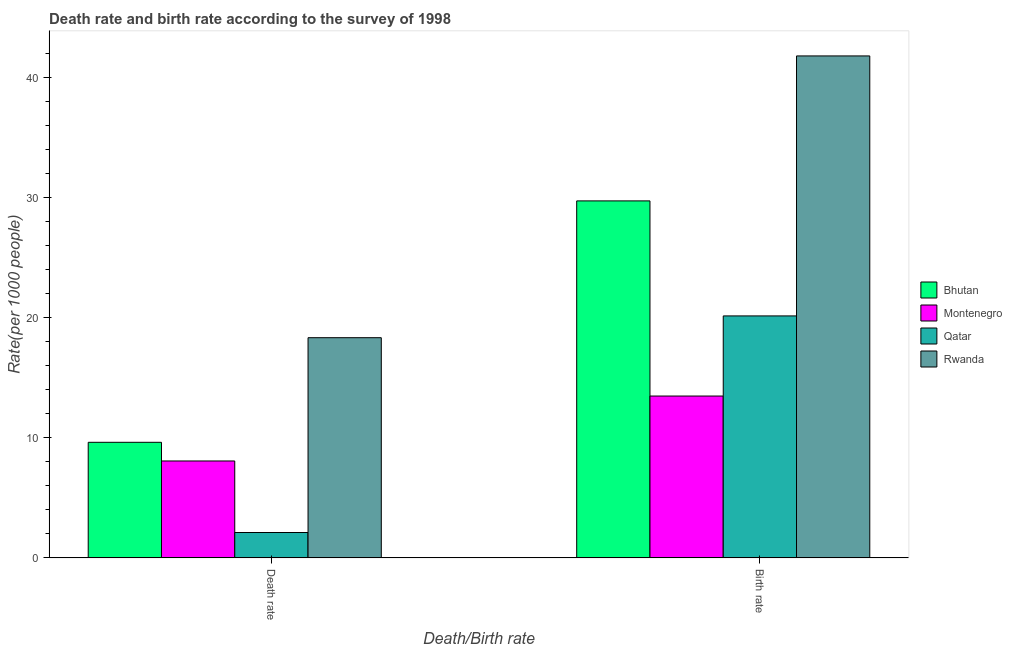How many different coloured bars are there?
Provide a succinct answer. 4. How many bars are there on the 1st tick from the left?
Give a very brief answer. 4. How many bars are there on the 2nd tick from the right?
Your response must be concise. 4. What is the label of the 2nd group of bars from the left?
Your response must be concise. Birth rate. What is the death rate in Montenegro?
Keep it short and to the point. 8.07. Across all countries, what is the maximum death rate?
Give a very brief answer. 18.32. Across all countries, what is the minimum death rate?
Ensure brevity in your answer.  2.11. In which country was the death rate maximum?
Provide a succinct answer. Rwanda. In which country was the death rate minimum?
Your response must be concise. Qatar. What is the total birth rate in the graph?
Keep it short and to the point. 105.09. What is the difference between the birth rate in Qatar and that in Montenegro?
Offer a very short reply. 6.67. What is the difference between the death rate in Qatar and the birth rate in Montenegro?
Ensure brevity in your answer.  -11.36. What is the average birth rate per country?
Your answer should be compact. 26.27. What is the difference between the death rate and birth rate in Qatar?
Keep it short and to the point. -18.03. What is the ratio of the death rate in Montenegro to that in Rwanda?
Give a very brief answer. 0.44. Is the birth rate in Montenegro less than that in Qatar?
Provide a succinct answer. Yes. In how many countries, is the death rate greater than the average death rate taken over all countries?
Your answer should be compact. 2. What does the 3rd bar from the left in Death rate represents?
Offer a very short reply. Qatar. What does the 3rd bar from the right in Death rate represents?
Your answer should be compact. Montenegro. Are all the bars in the graph horizontal?
Ensure brevity in your answer.  No. What is the difference between two consecutive major ticks on the Y-axis?
Provide a short and direct response. 10. Does the graph contain any zero values?
Your response must be concise. No. Where does the legend appear in the graph?
Provide a succinct answer. Center right. How many legend labels are there?
Your answer should be very brief. 4. What is the title of the graph?
Your response must be concise. Death rate and birth rate according to the survey of 1998. What is the label or title of the X-axis?
Provide a succinct answer. Death/Birth rate. What is the label or title of the Y-axis?
Keep it short and to the point. Rate(per 1000 people). What is the Rate(per 1000 people) in Bhutan in Death rate?
Keep it short and to the point. 9.62. What is the Rate(per 1000 people) in Montenegro in Death rate?
Your answer should be compact. 8.07. What is the Rate(per 1000 people) of Qatar in Death rate?
Offer a very short reply. 2.11. What is the Rate(per 1000 people) of Rwanda in Death rate?
Your answer should be very brief. 18.32. What is the Rate(per 1000 people) of Bhutan in Birth rate?
Make the answer very short. 29.71. What is the Rate(per 1000 people) in Montenegro in Birth rate?
Ensure brevity in your answer.  13.47. What is the Rate(per 1000 people) of Qatar in Birth rate?
Your response must be concise. 20.14. What is the Rate(per 1000 people) of Rwanda in Birth rate?
Keep it short and to the point. 41.77. Across all Death/Birth rate, what is the maximum Rate(per 1000 people) in Bhutan?
Offer a very short reply. 29.71. Across all Death/Birth rate, what is the maximum Rate(per 1000 people) in Montenegro?
Make the answer very short. 13.47. Across all Death/Birth rate, what is the maximum Rate(per 1000 people) of Qatar?
Offer a very short reply. 20.14. Across all Death/Birth rate, what is the maximum Rate(per 1000 people) in Rwanda?
Keep it short and to the point. 41.77. Across all Death/Birth rate, what is the minimum Rate(per 1000 people) in Bhutan?
Keep it short and to the point. 9.62. Across all Death/Birth rate, what is the minimum Rate(per 1000 people) of Montenegro?
Give a very brief answer. 8.07. Across all Death/Birth rate, what is the minimum Rate(per 1000 people) of Qatar?
Offer a very short reply. 2.11. Across all Death/Birth rate, what is the minimum Rate(per 1000 people) in Rwanda?
Offer a very short reply. 18.32. What is the total Rate(per 1000 people) of Bhutan in the graph?
Make the answer very short. 39.33. What is the total Rate(per 1000 people) in Montenegro in the graph?
Make the answer very short. 21.54. What is the total Rate(per 1000 people) in Qatar in the graph?
Make the answer very short. 22.25. What is the total Rate(per 1000 people) in Rwanda in the graph?
Your answer should be very brief. 60.1. What is the difference between the Rate(per 1000 people) in Bhutan in Death rate and that in Birth rate?
Provide a short and direct response. -20.09. What is the difference between the Rate(per 1000 people) in Montenegro in Death rate and that in Birth rate?
Your response must be concise. -5.4. What is the difference between the Rate(per 1000 people) of Qatar in Death rate and that in Birth rate?
Make the answer very short. -18.02. What is the difference between the Rate(per 1000 people) in Rwanda in Death rate and that in Birth rate?
Provide a succinct answer. -23.45. What is the difference between the Rate(per 1000 people) of Bhutan in Death rate and the Rate(per 1000 people) of Montenegro in Birth rate?
Keep it short and to the point. -3.85. What is the difference between the Rate(per 1000 people) in Bhutan in Death rate and the Rate(per 1000 people) in Qatar in Birth rate?
Offer a very short reply. -10.52. What is the difference between the Rate(per 1000 people) of Bhutan in Death rate and the Rate(per 1000 people) of Rwanda in Birth rate?
Your answer should be very brief. -32.16. What is the difference between the Rate(per 1000 people) in Montenegro in Death rate and the Rate(per 1000 people) in Qatar in Birth rate?
Provide a succinct answer. -12.07. What is the difference between the Rate(per 1000 people) in Montenegro in Death rate and the Rate(per 1000 people) in Rwanda in Birth rate?
Your answer should be very brief. -33.71. What is the difference between the Rate(per 1000 people) of Qatar in Death rate and the Rate(per 1000 people) of Rwanda in Birth rate?
Offer a very short reply. -39.66. What is the average Rate(per 1000 people) in Bhutan per Death/Birth rate?
Your answer should be compact. 19.66. What is the average Rate(per 1000 people) in Montenegro per Death/Birth rate?
Provide a succinct answer. 10.77. What is the average Rate(per 1000 people) in Qatar per Death/Birth rate?
Your answer should be compact. 11.13. What is the average Rate(per 1000 people) of Rwanda per Death/Birth rate?
Ensure brevity in your answer.  30.05. What is the difference between the Rate(per 1000 people) of Bhutan and Rate(per 1000 people) of Montenegro in Death rate?
Offer a terse response. 1.55. What is the difference between the Rate(per 1000 people) in Bhutan and Rate(per 1000 people) in Qatar in Death rate?
Make the answer very short. 7.51. What is the difference between the Rate(per 1000 people) of Bhutan and Rate(per 1000 people) of Rwanda in Death rate?
Your answer should be very brief. -8.71. What is the difference between the Rate(per 1000 people) in Montenegro and Rate(per 1000 people) in Qatar in Death rate?
Offer a very short reply. 5.95. What is the difference between the Rate(per 1000 people) in Montenegro and Rate(per 1000 people) in Rwanda in Death rate?
Offer a terse response. -10.26. What is the difference between the Rate(per 1000 people) of Qatar and Rate(per 1000 people) of Rwanda in Death rate?
Your answer should be compact. -16.21. What is the difference between the Rate(per 1000 people) of Bhutan and Rate(per 1000 people) of Montenegro in Birth rate?
Give a very brief answer. 16.24. What is the difference between the Rate(per 1000 people) of Bhutan and Rate(per 1000 people) of Qatar in Birth rate?
Keep it short and to the point. 9.57. What is the difference between the Rate(per 1000 people) in Bhutan and Rate(per 1000 people) in Rwanda in Birth rate?
Your answer should be very brief. -12.06. What is the difference between the Rate(per 1000 people) of Montenegro and Rate(per 1000 people) of Qatar in Birth rate?
Offer a very short reply. -6.67. What is the difference between the Rate(per 1000 people) of Montenegro and Rate(per 1000 people) of Rwanda in Birth rate?
Provide a succinct answer. -28.3. What is the difference between the Rate(per 1000 people) in Qatar and Rate(per 1000 people) in Rwanda in Birth rate?
Provide a short and direct response. -21.64. What is the ratio of the Rate(per 1000 people) in Bhutan in Death rate to that in Birth rate?
Make the answer very short. 0.32. What is the ratio of the Rate(per 1000 people) in Montenegro in Death rate to that in Birth rate?
Offer a terse response. 0.6. What is the ratio of the Rate(per 1000 people) in Qatar in Death rate to that in Birth rate?
Offer a very short reply. 0.1. What is the ratio of the Rate(per 1000 people) of Rwanda in Death rate to that in Birth rate?
Give a very brief answer. 0.44. What is the difference between the highest and the second highest Rate(per 1000 people) in Bhutan?
Your answer should be compact. 20.09. What is the difference between the highest and the second highest Rate(per 1000 people) in Montenegro?
Provide a succinct answer. 5.4. What is the difference between the highest and the second highest Rate(per 1000 people) of Qatar?
Keep it short and to the point. 18.02. What is the difference between the highest and the second highest Rate(per 1000 people) of Rwanda?
Your answer should be compact. 23.45. What is the difference between the highest and the lowest Rate(per 1000 people) in Bhutan?
Ensure brevity in your answer.  20.09. What is the difference between the highest and the lowest Rate(per 1000 people) in Montenegro?
Provide a succinct answer. 5.4. What is the difference between the highest and the lowest Rate(per 1000 people) of Qatar?
Your answer should be compact. 18.02. What is the difference between the highest and the lowest Rate(per 1000 people) in Rwanda?
Provide a short and direct response. 23.45. 